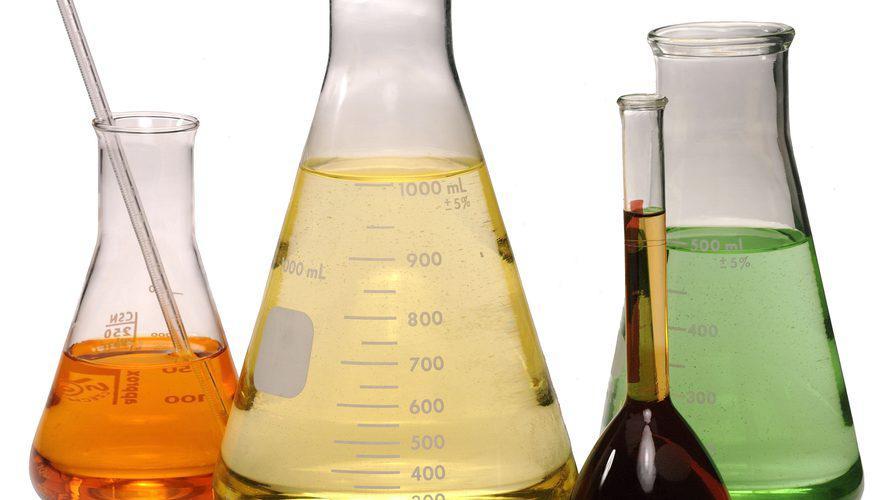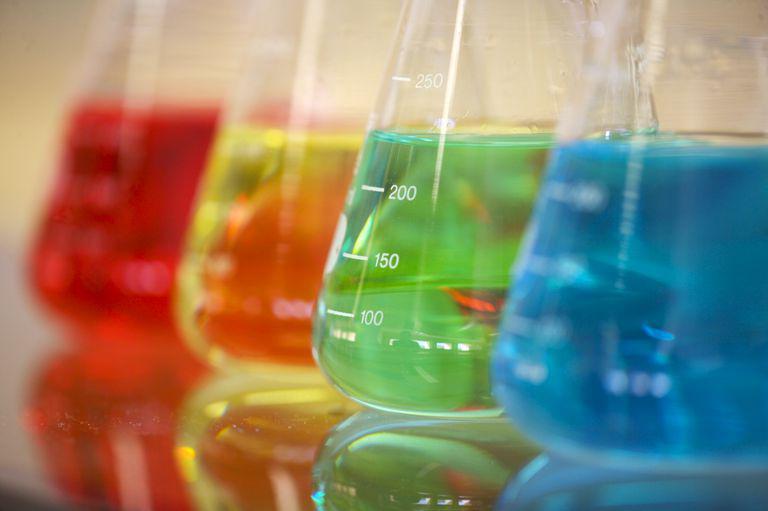The first image is the image on the left, the second image is the image on the right. For the images shown, is this caption "The image on the right has at least 4 beakers." true? Answer yes or no. Yes. The first image is the image on the left, the second image is the image on the right. Considering the images on both sides, is "There are less than nine containers." valid? Answer yes or no. Yes. 